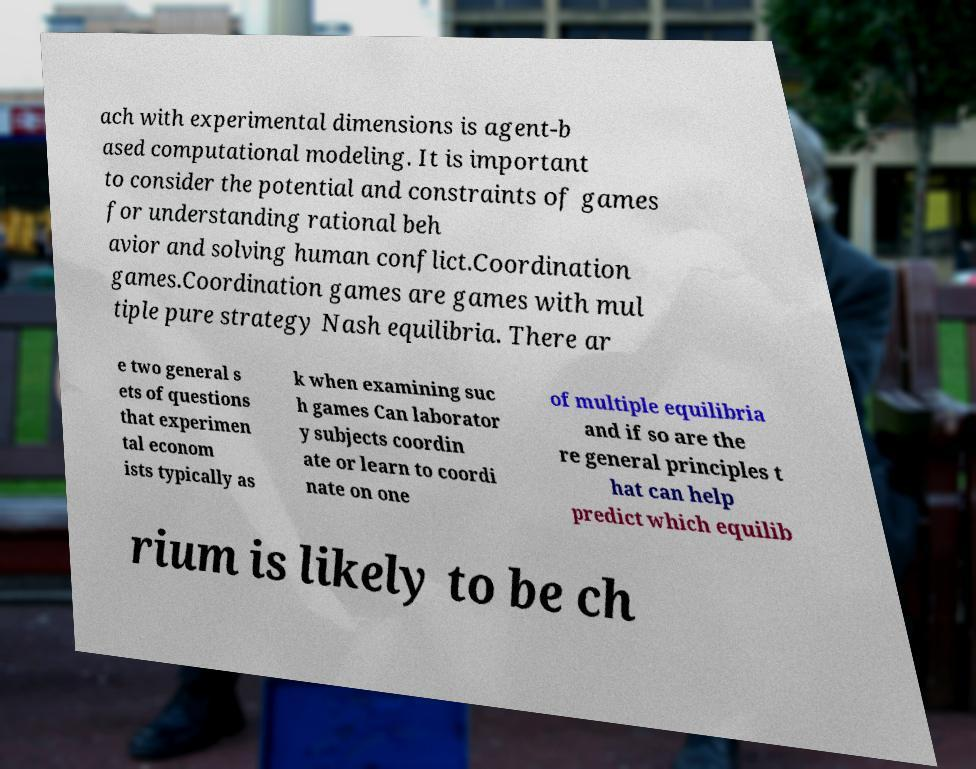I need the written content from this picture converted into text. Can you do that? ach with experimental dimensions is agent-b ased computational modeling. It is important to consider the potential and constraints of games for understanding rational beh avior and solving human conflict.Coordination games.Coordination games are games with mul tiple pure strategy Nash equilibria. There ar e two general s ets of questions that experimen tal econom ists typically as k when examining suc h games Can laborator y subjects coordin ate or learn to coordi nate on one of multiple equilibria and if so are the re general principles t hat can help predict which equilib rium is likely to be ch 